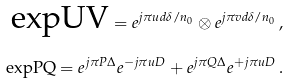<formula> <loc_0><loc_0><loc_500><loc_500>\text {expUV} = e ^ { j \pi u d \delta / n _ { 0 } } \otimes e ^ { j \pi v d \delta / n _ { 0 } } \, , \\ \text {expPQ} = e ^ { j \pi P \Delta } e ^ { - j \pi u D } + e ^ { j \pi Q \Delta } e ^ { + j \pi u D } \, .</formula> 